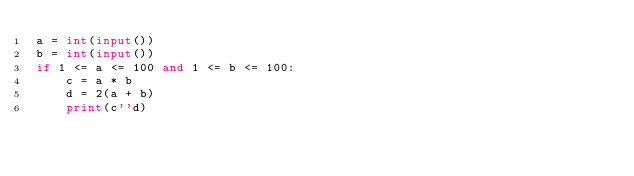<code> <loc_0><loc_0><loc_500><loc_500><_Python_>a = int(input())
b = int(input())
if 1 <= a <= 100 and 1 <= b <= 100:
    c = a * b
    d = 2(a + b)
    print(c''d)  </code> 